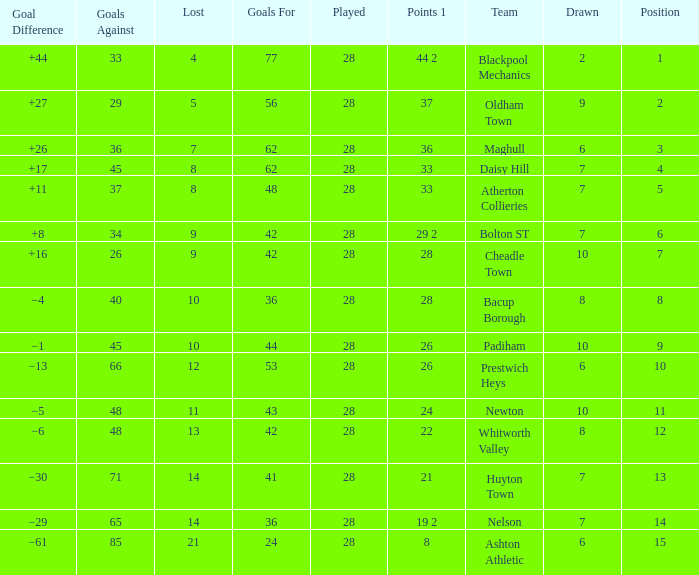What is the lowest drawn for entries with a lost of 13? 8.0. 